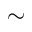<formula> <loc_0><loc_0><loc_500><loc_500>\sim</formula> 